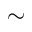<formula> <loc_0><loc_0><loc_500><loc_500>\sim</formula> 